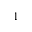Convert formula to latex. <formula><loc_0><loc_0><loc_500><loc_500>1</formula> 